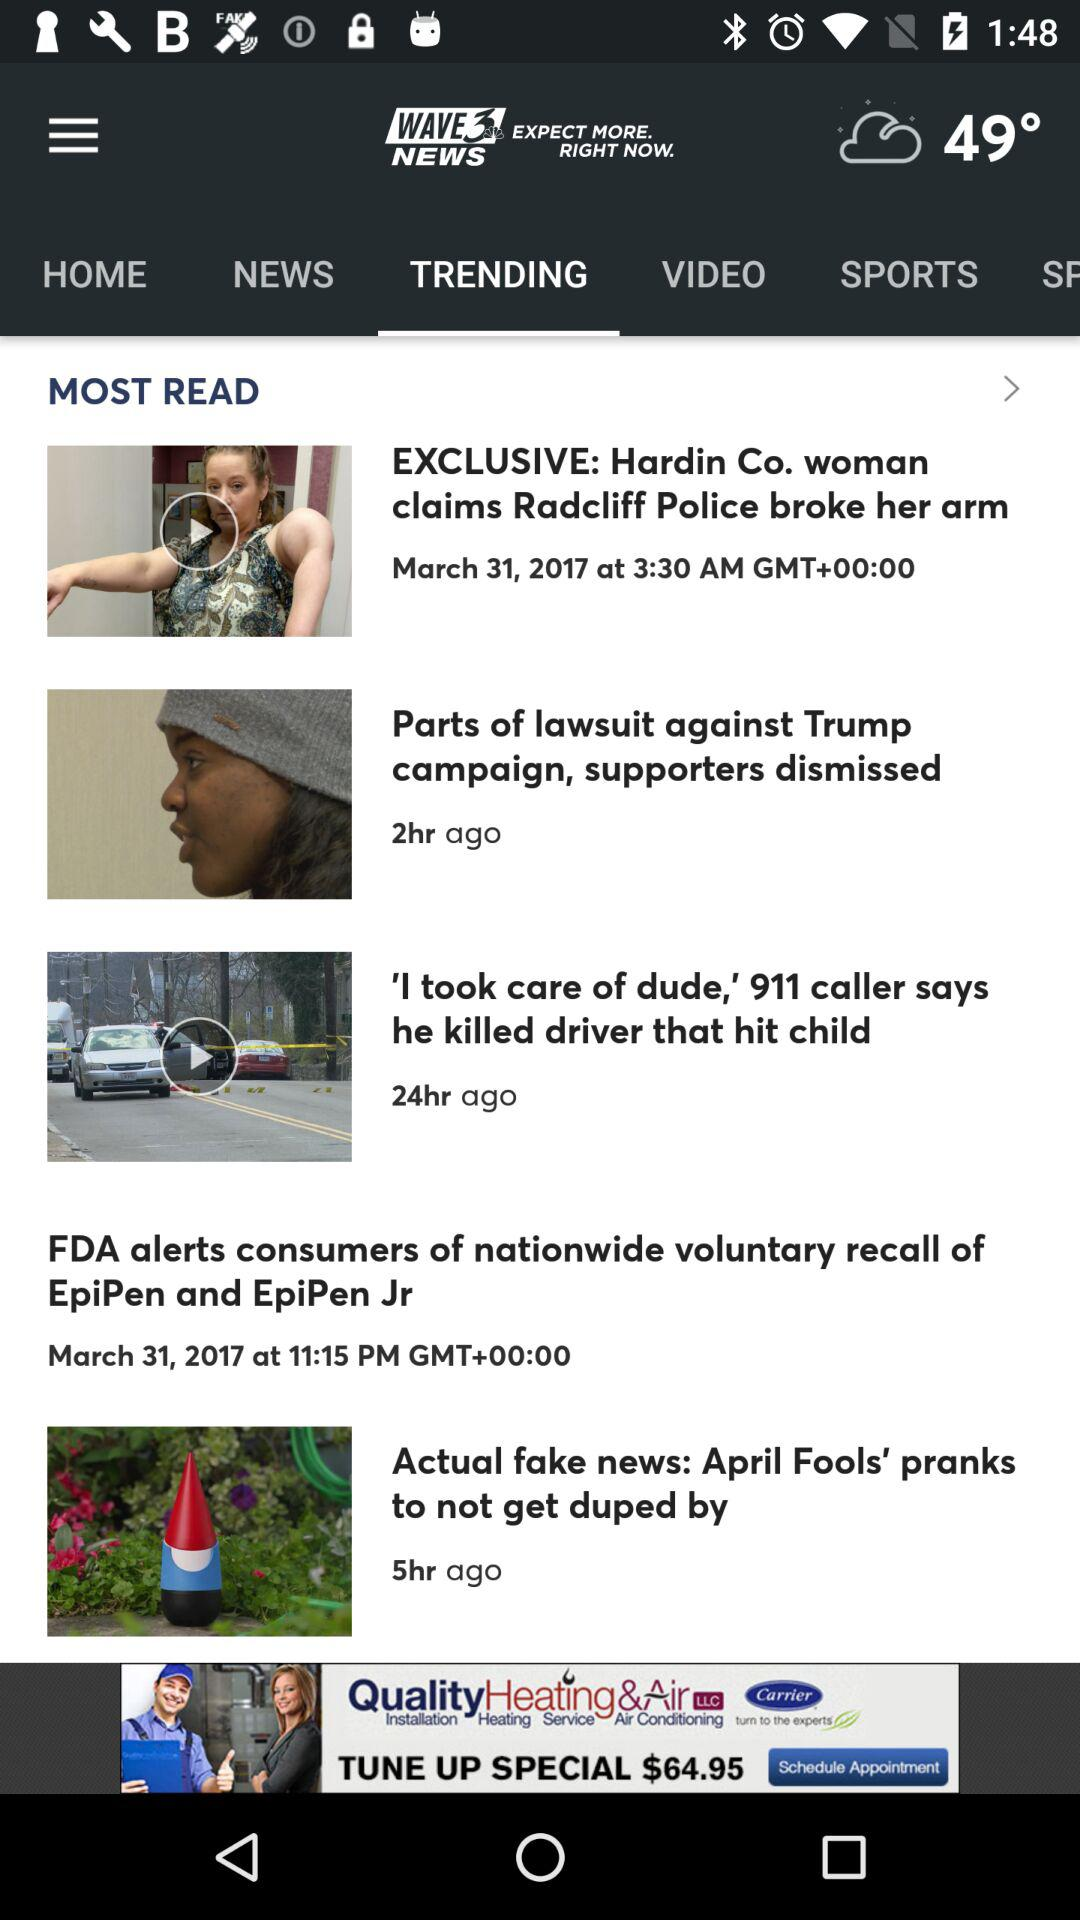What is the temperature? The temperature is 49°. 